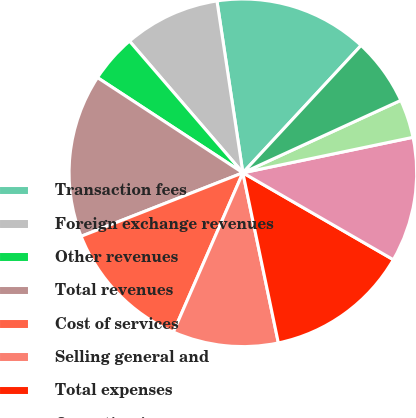<chart> <loc_0><loc_0><loc_500><loc_500><pie_chart><fcel>Transaction fees<fcel>Foreign exchange revenues<fcel>Other revenues<fcel>Total revenues<fcel>Cost of services<fcel>Selling general and<fcel>Total expenses<fcel>Operating income<fcel>Interest income<fcel>Interest expense<nl><fcel>14.29%<fcel>8.93%<fcel>4.46%<fcel>15.18%<fcel>12.5%<fcel>9.82%<fcel>13.39%<fcel>11.61%<fcel>3.57%<fcel>6.25%<nl></chart> 